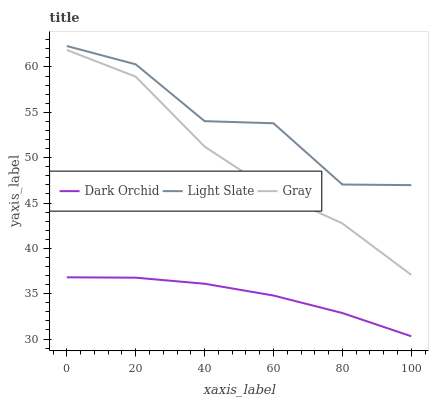Does Dark Orchid have the minimum area under the curve?
Answer yes or no. Yes. Does Light Slate have the maximum area under the curve?
Answer yes or no. Yes. Does Gray have the minimum area under the curve?
Answer yes or no. No. Does Gray have the maximum area under the curve?
Answer yes or no. No. Is Dark Orchid the smoothest?
Answer yes or no. Yes. Is Light Slate the roughest?
Answer yes or no. Yes. Is Gray the smoothest?
Answer yes or no. No. Is Gray the roughest?
Answer yes or no. No. Does Dark Orchid have the lowest value?
Answer yes or no. Yes. Does Gray have the lowest value?
Answer yes or no. No. Does Light Slate have the highest value?
Answer yes or no. Yes. Does Gray have the highest value?
Answer yes or no. No. Is Dark Orchid less than Gray?
Answer yes or no. Yes. Is Gray greater than Dark Orchid?
Answer yes or no. Yes. Does Dark Orchid intersect Gray?
Answer yes or no. No. 